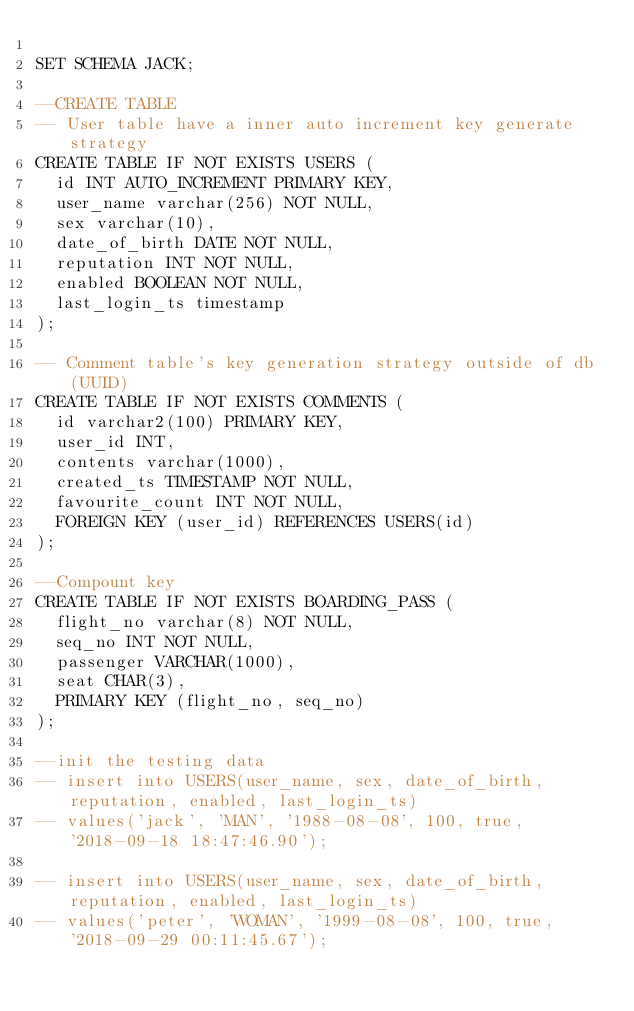<code> <loc_0><loc_0><loc_500><loc_500><_SQL_>
SET SCHEMA JACK;

--CREATE TABLE
-- User table have a inner auto increment key generate strategy
CREATE TABLE IF NOT EXISTS USERS (
  id INT AUTO_INCREMENT PRIMARY KEY,
  user_name varchar(256) NOT NULL,
  sex varchar(10),
  date_of_birth DATE NOT NULL,
  reputation INT NOT NULL,
  enabled BOOLEAN NOT NULL,
  last_login_ts timestamp
);

-- Comment table's key generation strategy outside of db (UUID)
CREATE TABLE IF NOT EXISTS COMMENTS (
  id varchar2(100) PRIMARY KEY,
  user_id INT,
  contents varchar(1000),
  created_ts TIMESTAMP NOT NULL,
  favourite_count INT NOT NULL,
  FOREIGN KEY (user_id) REFERENCES USERS(id)
);

--Compount key
CREATE TABLE IF NOT EXISTS BOARDING_PASS (
  flight_no varchar(8) NOT NULL,
  seq_no INT NOT NULL,
  passenger VARCHAR(1000),
  seat CHAR(3),
  PRIMARY KEY (flight_no, seq_no)
);

--init the testing data
-- insert into USERS(user_name, sex, date_of_birth, reputation, enabled, last_login_ts)
-- values('jack', 'MAN', '1988-08-08', 100, true, '2018-09-18 18:47:46.90');

-- insert into USERS(user_name, sex, date_of_birth, reputation, enabled, last_login_ts)
-- values('peter', 'WOMAN', '1999-08-08', 100, true, '2018-09-29 00:11:45.67');
</code> 